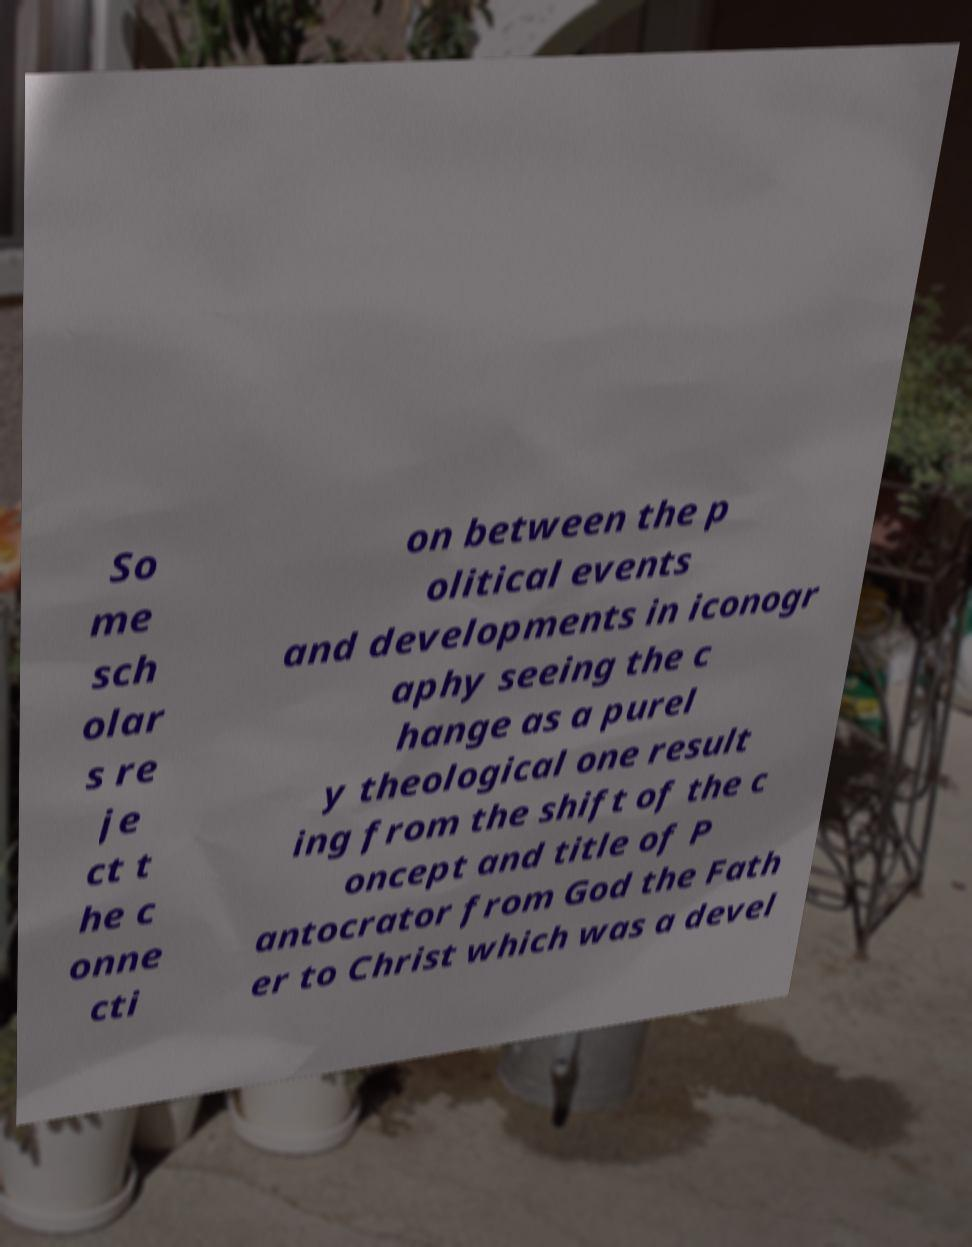Please identify and transcribe the text found in this image. So me sch olar s re je ct t he c onne cti on between the p olitical events and developments in iconogr aphy seeing the c hange as a purel y theological one result ing from the shift of the c oncept and title of P antocrator from God the Fath er to Christ which was a devel 